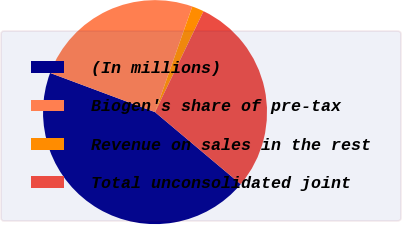Convert chart. <chart><loc_0><loc_0><loc_500><loc_500><pie_chart><fcel>(In millions)<fcel>Biogen's share of pre-tax<fcel>Revenue on sales in the rest<fcel>Total unconsolidated joint<nl><fcel>44.56%<fcel>24.71%<fcel>1.73%<fcel>29.0%<nl></chart> 